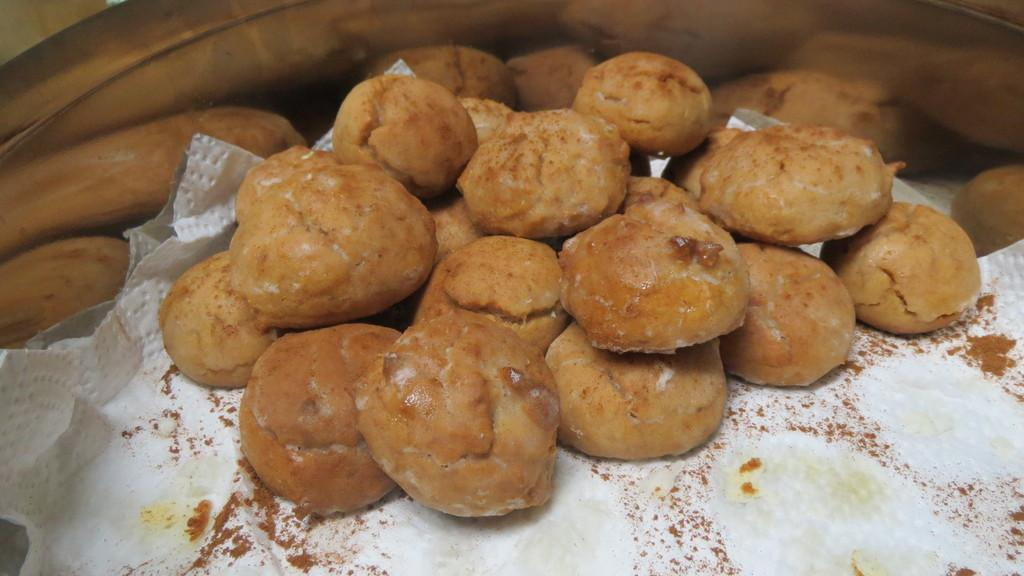What types of items can be seen in the image? There are food items and tissue paper in the image. How are the food items and tissue paper arranged in the image? The food items and tissue paper are kept in a bowl. What type of hydrant is visible in the image? There is no hydrant present in the image. What color are the trousers worn by the person in the image? There is no person or trousers visible in the image. 